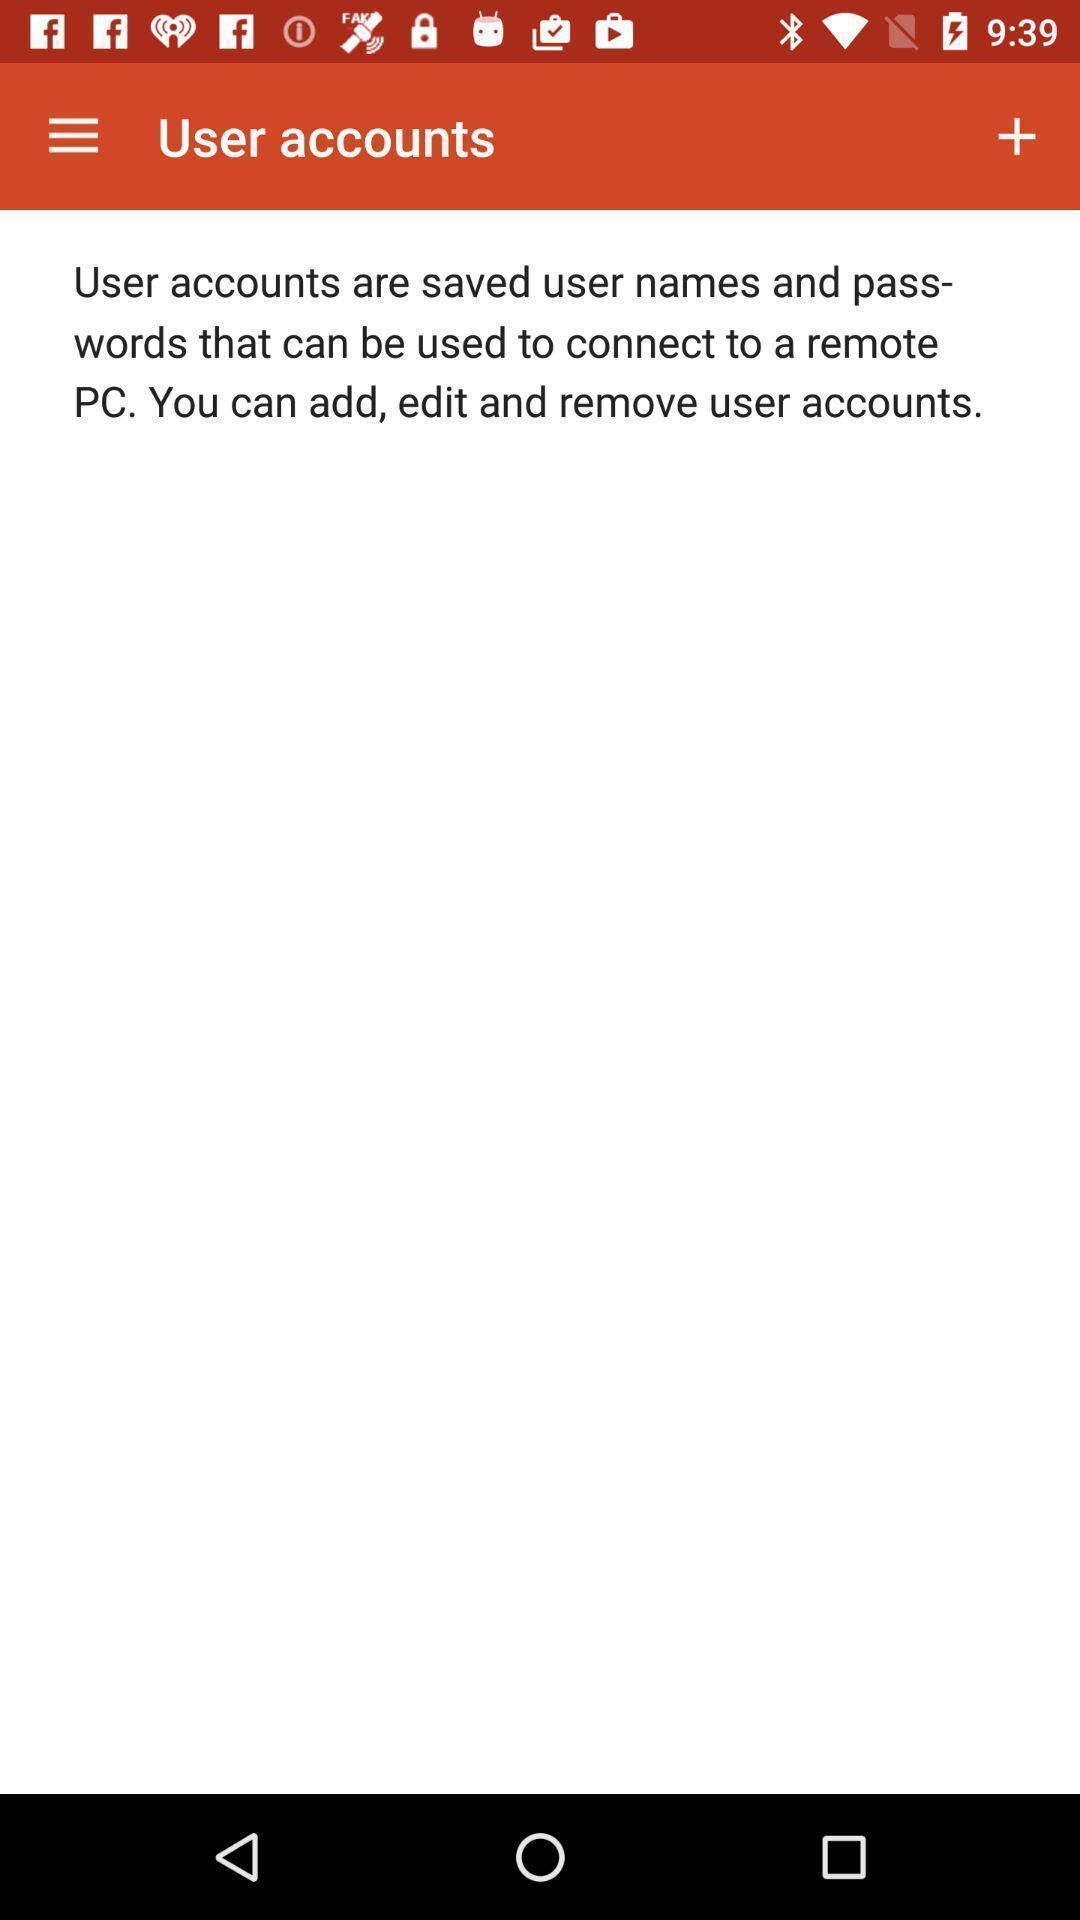Describe this image in words. Page displaying the user accounts. 